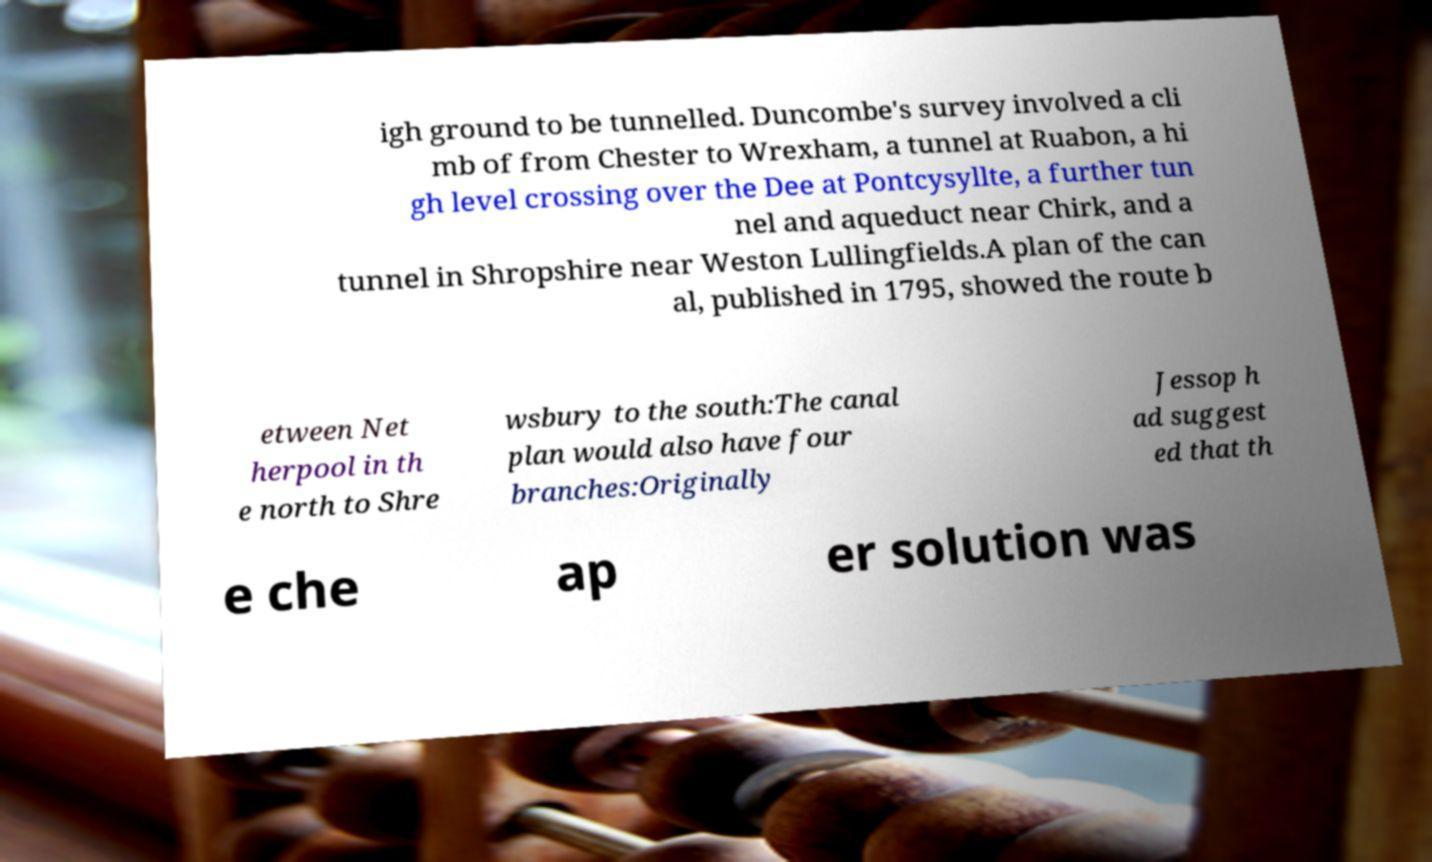Could you extract and type out the text from this image? igh ground to be tunnelled. Duncombe's survey involved a cli mb of from Chester to Wrexham, a tunnel at Ruabon, a hi gh level crossing over the Dee at Pontcysyllte, a further tun nel and aqueduct near Chirk, and a tunnel in Shropshire near Weston Lullingfields.A plan of the can al, published in 1795, showed the route b etween Net herpool in th e north to Shre wsbury to the south:The canal plan would also have four branches:Originally Jessop h ad suggest ed that th e che ap er solution was 